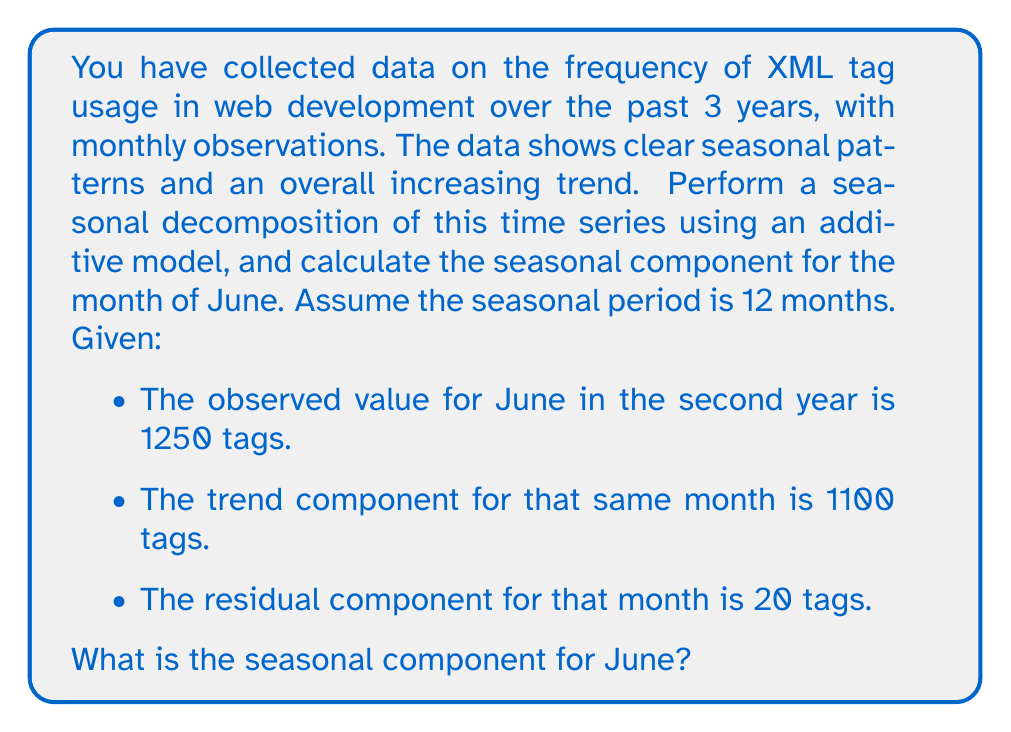Provide a solution to this math problem. To perform a seasonal decomposition using an additive model, we use the following equation:

$$ Y_t = T_t + S_t + R_t $$

Where:
$Y_t$ is the observed value
$T_t$ is the trend component
$S_t$ is the seasonal component
$R_t$ is the residual (or irregular) component

For the additive model, these components are summed to create the observed value. To find the seasonal component, we can rearrange the equation:

$$ S_t = Y_t - T_t - R_t $$

We are given the following information for June in the second year:
- Observed value ($Y_t$): 1250 tags
- Trend component ($T_t$): 1100 tags
- Residual component ($R_t$): 20 tags

Substituting these values into the equation:

$$ S_t = 1250 - 1100 - 20 $$

$$ S_t = 130 $$

This value represents the seasonal component for June. In the context of XML tag usage, it suggests that there is a seasonal increase of 130 tags in June compared to the trend, which could be due to factors such as increased web development activity during this month.
Answer: The seasonal component for June is 130 tags. 